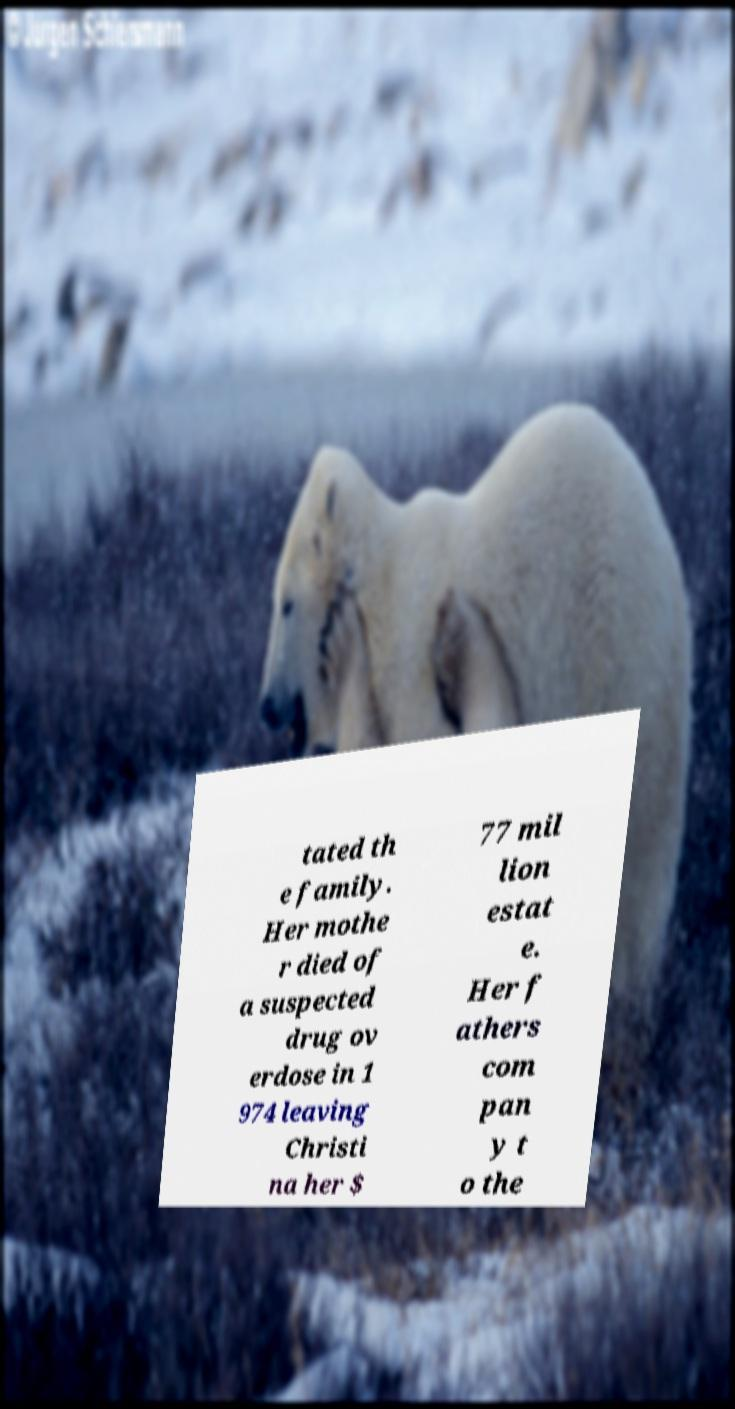I need the written content from this picture converted into text. Can you do that? tated th e family. Her mothe r died of a suspected drug ov erdose in 1 974 leaving Christi na her $ 77 mil lion estat e. Her f athers com pan y t o the 